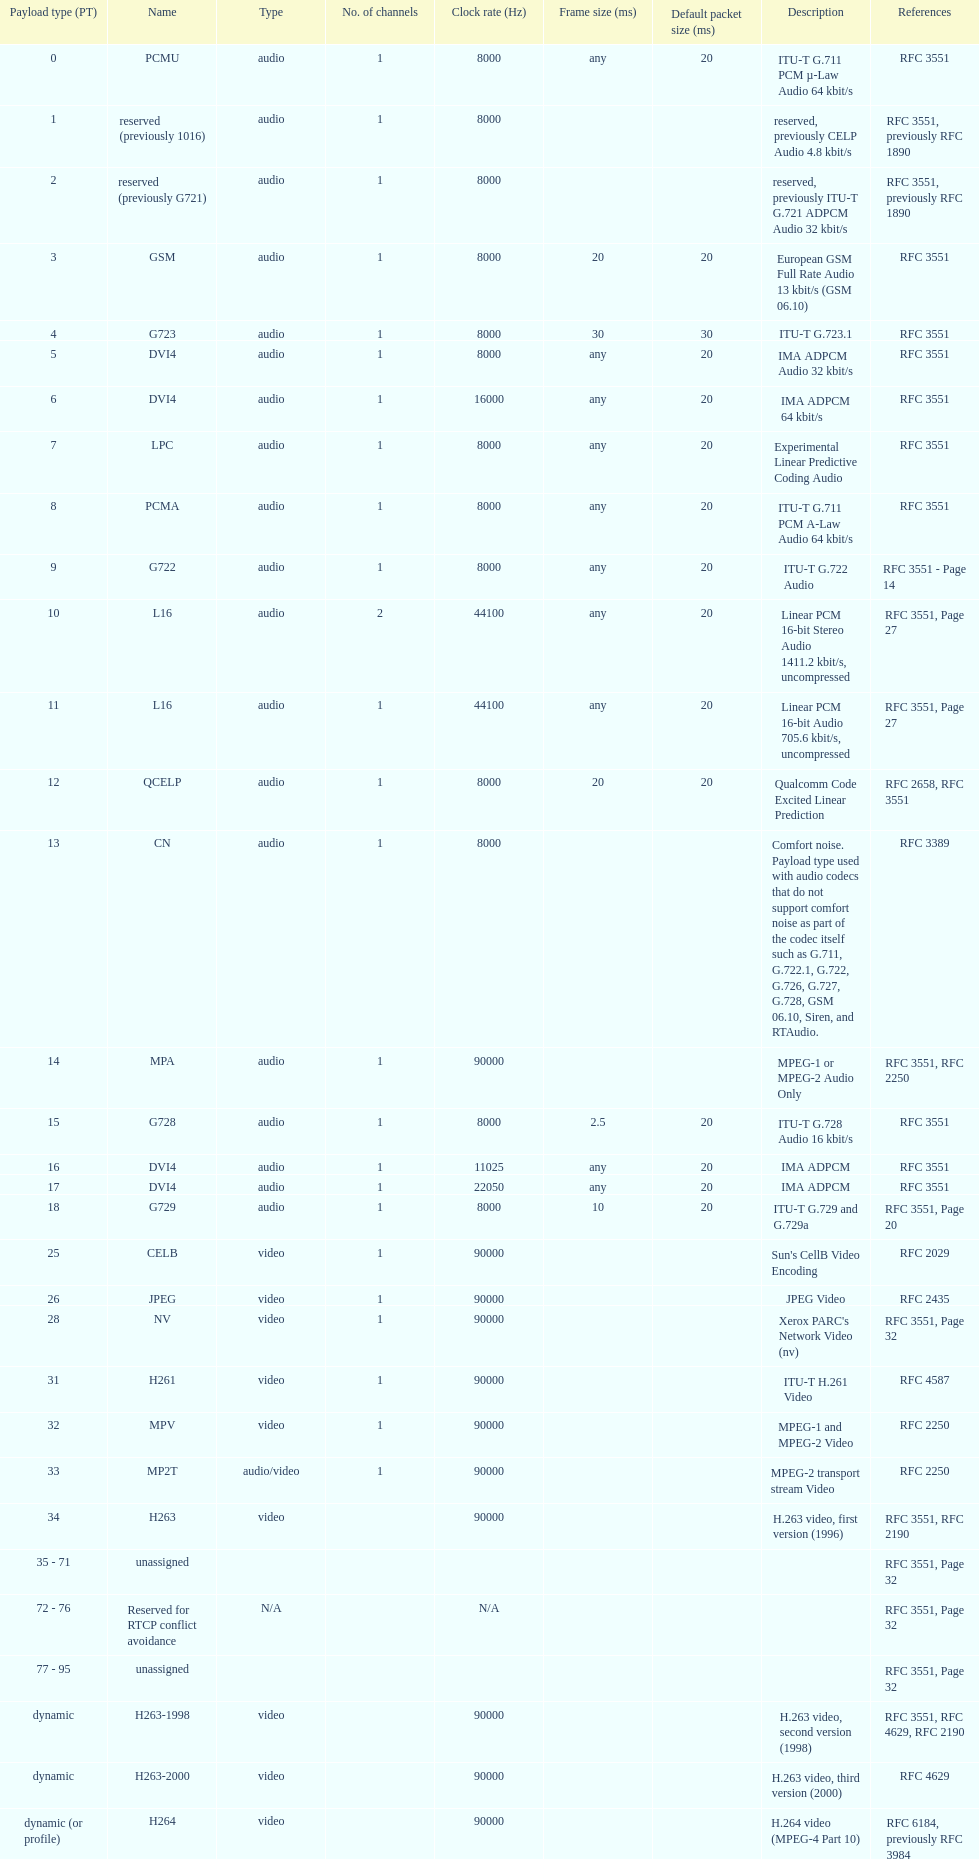What is the average number of channels? 1. 